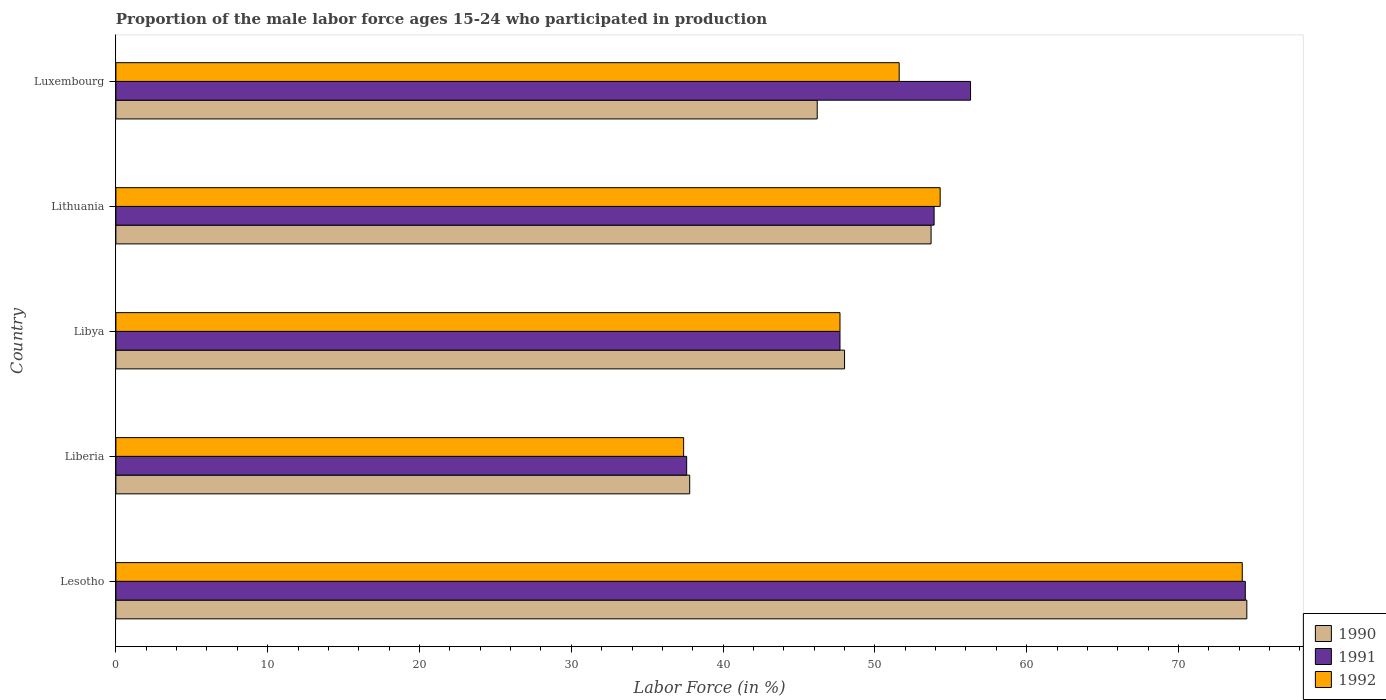How many different coloured bars are there?
Provide a short and direct response. 3. Are the number of bars per tick equal to the number of legend labels?
Provide a short and direct response. Yes. How many bars are there on the 2nd tick from the bottom?
Make the answer very short. 3. What is the label of the 3rd group of bars from the top?
Your answer should be very brief. Libya. In how many cases, is the number of bars for a given country not equal to the number of legend labels?
Give a very brief answer. 0. What is the proportion of the male labor force who participated in production in 1990 in Luxembourg?
Ensure brevity in your answer.  46.2. Across all countries, what is the maximum proportion of the male labor force who participated in production in 1990?
Ensure brevity in your answer.  74.5. Across all countries, what is the minimum proportion of the male labor force who participated in production in 1991?
Your response must be concise. 37.6. In which country was the proportion of the male labor force who participated in production in 1991 maximum?
Your response must be concise. Lesotho. In which country was the proportion of the male labor force who participated in production in 1992 minimum?
Offer a very short reply. Liberia. What is the total proportion of the male labor force who participated in production in 1990 in the graph?
Make the answer very short. 260.2. What is the difference between the proportion of the male labor force who participated in production in 1991 in Liberia and the proportion of the male labor force who participated in production in 1990 in Lithuania?
Your response must be concise. -16.1. What is the average proportion of the male labor force who participated in production in 1992 per country?
Provide a succinct answer. 53.04. What is the difference between the proportion of the male labor force who participated in production in 1990 and proportion of the male labor force who participated in production in 1991 in Libya?
Provide a short and direct response. 0.3. What is the ratio of the proportion of the male labor force who participated in production in 1990 in Liberia to that in Libya?
Your answer should be very brief. 0.79. What is the difference between the highest and the second highest proportion of the male labor force who participated in production in 1991?
Provide a succinct answer. 18.1. What is the difference between the highest and the lowest proportion of the male labor force who participated in production in 1990?
Provide a succinct answer. 36.7. What does the 2nd bar from the top in Lesotho represents?
Give a very brief answer. 1991. Is it the case that in every country, the sum of the proportion of the male labor force who participated in production in 1991 and proportion of the male labor force who participated in production in 1992 is greater than the proportion of the male labor force who participated in production in 1990?
Offer a very short reply. Yes. Are all the bars in the graph horizontal?
Ensure brevity in your answer.  Yes. How many countries are there in the graph?
Ensure brevity in your answer.  5. Does the graph contain grids?
Your answer should be very brief. No. Where does the legend appear in the graph?
Your answer should be very brief. Bottom right. How many legend labels are there?
Give a very brief answer. 3. How are the legend labels stacked?
Keep it short and to the point. Vertical. What is the title of the graph?
Make the answer very short. Proportion of the male labor force ages 15-24 who participated in production. Does "1971" appear as one of the legend labels in the graph?
Ensure brevity in your answer.  No. What is the label or title of the X-axis?
Your answer should be compact. Labor Force (in %). What is the Labor Force (in %) in 1990 in Lesotho?
Keep it short and to the point. 74.5. What is the Labor Force (in %) in 1991 in Lesotho?
Give a very brief answer. 74.4. What is the Labor Force (in %) in 1992 in Lesotho?
Offer a terse response. 74.2. What is the Labor Force (in %) in 1990 in Liberia?
Your answer should be very brief. 37.8. What is the Labor Force (in %) in 1991 in Liberia?
Give a very brief answer. 37.6. What is the Labor Force (in %) of 1992 in Liberia?
Your answer should be compact. 37.4. What is the Labor Force (in %) in 1991 in Libya?
Your response must be concise. 47.7. What is the Labor Force (in %) in 1992 in Libya?
Provide a succinct answer. 47.7. What is the Labor Force (in %) in 1990 in Lithuania?
Offer a very short reply. 53.7. What is the Labor Force (in %) in 1991 in Lithuania?
Ensure brevity in your answer.  53.9. What is the Labor Force (in %) of 1992 in Lithuania?
Make the answer very short. 54.3. What is the Labor Force (in %) of 1990 in Luxembourg?
Your answer should be compact. 46.2. What is the Labor Force (in %) in 1991 in Luxembourg?
Your answer should be compact. 56.3. What is the Labor Force (in %) in 1992 in Luxembourg?
Make the answer very short. 51.6. Across all countries, what is the maximum Labor Force (in %) in 1990?
Offer a very short reply. 74.5. Across all countries, what is the maximum Labor Force (in %) in 1991?
Provide a succinct answer. 74.4. Across all countries, what is the maximum Labor Force (in %) of 1992?
Keep it short and to the point. 74.2. Across all countries, what is the minimum Labor Force (in %) in 1990?
Your answer should be compact. 37.8. Across all countries, what is the minimum Labor Force (in %) of 1991?
Keep it short and to the point. 37.6. Across all countries, what is the minimum Labor Force (in %) of 1992?
Give a very brief answer. 37.4. What is the total Labor Force (in %) of 1990 in the graph?
Keep it short and to the point. 260.2. What is the total Labor Force (in %) in 1991 in the graph?
Provide a succinct answer. 269.9. What is the total Labor Force (in %) in 1992 in the graph?
Keep it short and to the point. 265.2. What is the difference between the Labor Force (in %) in 1990 in Lesotho and that in Liberia?
Your response must be concise. 36.7. What is the difference between the Labor Force (in %) of 1991 in Lesotho and that in Liberia?
Ensure brevity in your answer.  36.8. What is the difference between the Labor Force (in %) in 1992 in Lesotho and that in Liberia?
Keep it short and to the point. 36.8. What is the difference between the Labor Force (in %) of 1990 in Lesotho and that in Libya?
Keep it short and to the point. 26.5. What is the difference between the Labor Force (in %) in 1991 in Lesotho and that in Libya?
Offer a very short reply. 26.7. What is the difference between the Labor Force (in %) in 1990 in Lesotho and that in Lithuania?
Provide a short and direct response. 20.8. What is the difference between the Labor Force (in %) in 1991 in Lesotho and that in Lithuania?
Offer a terse response. 20.5. What is the difference between the Labor Force (in %) in 1992 in Lesotho and that in Lithuania?
Keep it short and to the point. 19.9. What is the difference between the Labor Force (in %) in 1990 in Lesotho and that in Luxembourg?
Your answer should be compact. 28.3. What is the difference between the Labor Force (in %) of 1992 in Lesotho and that in Luxembourg?
Your response must be concise. 22.6. What is the difference between the Labor Force (in %) of 1990 in Liberia and that in Libya?
Your answer should be compact. -10.2. What is the difference between the Labor Force (in %) of 1992 in Liberia and that in Libya?
Make the answer very short. -10.3. What is the difference between the Labor Force (in %) in 1990 in Liberia and that in Lithuania?
Your response must be concise. -15.9. What is the difference between the Labor Force (in %) in 1991 in Liberia and that in Lithuania?
Make the answer very short. -16.3. What is the difference between the Labor Force (in %) in 1992 in Liberia and that in Lithuania?
Give a very brief answer. -16.9. What is the difference between the Labor Force (in %) in 1990 in Liberia and that in Luxembourg?
Your response must be concise. -8.4. What is the difference between the Labor Force (in %) of 1991 in Liberia and that in Luxembourg?
Offer a very short reply. -18.7. What is the difference between the Labor Force (in %) of 1990 in Libya and that in Lithuania?
Keep it short and to the point. -5.7. What is the difference between the Labor Force (in %) in 1991 in Libya and that in Lithuania?
Give a very brief answer. -6.2. What is the difference between the Labor Force (in %) of 1992 in Libya and that in Lithuania?
Offer a very short reply. -6.6. What is the difference between the Labor Force (in %) in 1990 in Libya and that in Luxembourg?
Your answer should be very brief. 1.8. What is the difference between the Labor Force (in %) of 1992 in Libya and that in Luxembourg?
Your response must be concise. -3.9. What is the difference between the Labor Force (in %) of 1990 in Lithuania and that in Luxembourg?
Provide a short and direct response. 7.5. What is the difference between the Labor Force (in %) of 1991 in Lithuania and that in Luxembourg?
Give a very brief answer. -2.4. What is the difference between the Labor Force (in %) in 1990 in Lesotho and the Labor Force (in %) in 1991 in Liberia?
Ensure brevity in your answer.  36.9. What is the difference between the Labor Force (in %) of 1990 in Lesotho and the Labor Force (in %) of 1992 in Liberia?
Offer a very short reply. 37.1. What is the difference between the Labor Force (in %) in 1991 in Lesotho and the Labor Force (in %) in 1992 in Liberia?
Make the answer very short. 37. What is the difference between the Labor Force (in %) of 1990 in Lesotho and the Labor Force (in %) of 1991 in Libya?
Ensure brevity in your answer.  26.8. What is the difference between the Labor Force (in %) of 1990 in Lesotho and the Labor Force (in %) of 1992 in Libya?
Offer a terse response. 26.8. What is the difference between the Labor Force (in %) of 1991 in Lesotho and the Labor Force (in %) of 1992 in Libya?
Offer a very short reply. 26.7. What is the difference between the Labor Force (in %) in 1990 in Lesotho and the Labor Force (in %) in 1991 in Lithuania?
Offer a terse response. 20.6. What is the difference between the Labor Force (in %) in 1990 in Lesotho and the Labor Force (in %) in 1992 in Lithuania?
Your response must be concise. 20.2. What is the difference between the Labor Force (in %) in 1991 in Lesotho and the Labor Force (in %) in 1992 in Lithuania?
Ensure brevity in your answer.  20.1. What is the difference between the Labor Force (in %) of 1990 in Lesotho and the Labor Force (in %) of 1991 in Luxembourg?
Offer a very short reply. 18.2. What is the difference between the Labor Force (in %) of 1990 in Lesotho and the Labor Force (in %) of 1992 in Luxembourg?
Provide a short and direct response. 22.9. What is the difference between the Labor Force (in %) of 1991 in Lesotho and the Labor Force (in %) of 1992 in Luxembourg?
Keep it short and to the point. 22.8. What is the difference between the Labor Force (in %) of 1990 in Liberia and the Labor Force (in %) of 1992 in Libya?
Make the answer very short. -9.9. What is the difference between the Labor Force (in %) in 1991 in Liberia and the Labor Force (in %) in 1992 in Libya?
Your answer should be very brief. -10.1. What is the difference between the Labor Force (in %) in 1990 in Liberia and the Labor Force (in %) in 1991 in Lithuania?
Provide a succinct answer. -16.1. What is the difference between the Labor Force (in %) of 1990 in Liberia and the Labor Force (in %) of 1992 in Lithuania?
Ensure brevity in your answer.  -16.5. What is the difference between the Labor Force (in %) of 1991 in Liberia and the Labor Force (in %) of 1992 in Lithuania?
Make the answer very short. -16.7. What is the difference between the Labor Force (in %) in 1990 in Liberia and the Labor Force (in %) in 1991 in Luxembourg?
Ensure brevity in your answer.  -18.5. What is the difference between the Labor Force (in %) in 1991 in Liberia and the Labor Force (in %) in 1992 in Luxembourg?
Provide a short and direct response. -14. What is the difference between the Labor Force (in %) in 1990 in Libya and the Labor Force (in %) in 1991 in Lithuania?
Your answer should be very brief. -5.9. What is the difference between the Labor Force (in %) in 1990 in Libya and the Labor Force (in %) in 1992 in Luxembourg?
Keep it short and to the point. -3.6. What is the difference between the Labor Force (in %) of 1990 in Lithuania and the Labor Force (in %) of 1991 in Luxembourg?
Your response must be concise. -2.6. What is the difference between the Labor Force (in %) of 1991 in Lithuania and the Labor Force (in %) of 1992 in Luxembourg?
Ensure brevity in your answer.  2.3. What is the average Labor Force (in %) in 1990 per country?
Your answer should be compact. 52.04. What is the average Labor Force (in %) of 1991 per country?
Provide a succinct answer. 53.98. What is the average Labor Force (in %) in 1992 per country?
Ensure brevity in your answer.  53.04. What is the difference between the Labor Force (in %) in 1990 and Labor Force (in %) in 1991 in Lesotho?
Your answer should be compact. 0.1. What is the difference between the Labor Force (in %) in 1990 and Labor Force (in %) in 1992 in Lesotho?
Provide a short and direct response. 0.3. What is the difference between the Labor Force (in %) in 1990 and Labor Force (in %) in 1992 in Liberia?
Offer a terse response. 0.4. What is the difference between the Labor Force (in %) of 1991 and Labor Force (in %) of 1992 in Liberia?
Your response must be concise. 0.2. What is the difference between the Labor Force (in %) of 1991 and Labor Force (in %) of 1992 in Libya?
Give a very brief answer. 0. What is the difference between the Labor Force (in %) of 1990 and Labor Force (in %) of 1991 in Lithuania?
Ensure brevity in your answer.  -0.2. What is the difference between the Labor Force (in %) of 1991 and Labor Force (in %) of 1992 in Lithuania?
Give a very brief answer. -0.4. What is the ratio of the Labor Force (in %) in 1990 in Lesotho to that in Liberia?
Keep it short and to the point. 1.97. What is the ratio of the Labor Force (in %) of 1991 in Lesotho to that in Liberia?
Make the answer very short. 1.98. What is the ratio of the Labor Force (in %) in 1992 in Lesotho to that in Liberia?
Keep it short and to the point. 1.98. What is the ratio of the Labor Force (in %) of 1990 in Lesotho to that in Libya?
Provide a succinct answer. 1.55. What is the ratio of the Labor Force (in %) of 1991 in Lesotho to that in Libya?
Offer a terse response. 1.56. What is the ratio of the Labor Force (in %) in 1992 in Lesotho to that in Libya?
Your answer should be compact. 1.56. What is the ratio of the Labor Force (in %) in 1990 in Lesotho to that in Lithuania?
Provide a succinct answer. 1.39. What is the ratio of the Labor Force (in %) in 1991 in Lesotho to that in Lithuania?
Provide a short and direct response. 1.38. What is the ratio of the Labor Force (in %) of 1992 in Lesotho to that in Lithuania?
Your answer should be compact. 1.37. What is the ratio of the Labor Force (in %) of 1990 in Lesotho to that in Luxembourg?
Keep it short and to the point. 1.61. What is the ratio of the Labor Force (in %) in 1991 in Lesotho to that in Luxembourg?
Offer a very short reply. 1.32. What is the ratio of the Labor Force (in %) in 1992 in Lesotho to that in Luxembourg?
Your response must be concise. 1.44. What is the ratio of the Labor Force (in %) in 1990 in Liberia to that in Libya?
Your response must be concise. 0.79. What is the ratio of the Labor Force (in %) in 1991 in Liberia to that in Libya?
Your response must be concise. 0.79. What is the ratio of the Labor Force (in %) of 1992 in Liberia to that in Libya?
Provide a short and direct response. 0.78. What is the ratio of the Labor Force (in %) of 1990 in Liberia to that in Lithuania?
Provide a succinct answer. 0.7. What is the ratio of the Labor Force (in %) of 1991 in Liberia to that in Lithuania?
Your answer should be compact. 0.7. What is the ratio of the Labor Force (in %) of 1992 in Liberia to that in Lithuania?
Ensure brevity in your answer.  0.69. What is the ratio of the Labor Force (in %) of 1990 in Liberia to that in Luxembourg?
Keep it short and to the point. 0.82. What is the ratio of the Labor Force (in %) in 1991 in Liberia to that in Luxembourg?
Keep it short and to the point. 0.67. What is the ratio of the Labor Force (in %) in 1992 in Liberia to that in Luxembourg?
Provide a short and direct response. 0.72. What is the ratio of the Labor Force (in %) in 1990 in Libya to that in Lithuania?
Provide a succinct answer. 0.89. What is the ratio of the Labor Force (in %) of 1991 in Libya to that in Lithuania?
Give a very brief answer. 0.89. What is the ratio of the Labor Force (in %) in 1992 in Libya to that in Lithuania?
Your answer should be compact. 0.88. What is the ratio of the Labor Force (in %) in 1990 in Libya to that in Luxembourg?
Your response must be concise. 1.04. What is the ratio of the Labor Force (in %) of 1991 in Libya to that in Luxembourg?
Ensure brevity in your answer.  0.85. What is the ratio of the Labor Force (in %) in 1992 in Libya to that in Luxembourg?
Your answer should be compact. 0.92. What is the ratio of the Labor Force (in %) of 1990 in Lithuania to that in Luxembourg?
Offer a very short reply. 1.16. What is the ratio of the Labor Force (in %) of 1991 in Lithuania to that in Luxembourg?
Provide a short and direct response. 0.96. What is the ratio of the Labor Force (in %) in 1992 in Lithuania to that in Luxembourg?
Keep it short and to the point. 1.05. What is the difference between the highest and the second highest Labor Force (in %) of 1990?
Provide a succinct answer. 20.8. What is the difference between the highest and the lowest Labor Force (in %) in 1990?
Provide a short and direct response. 36.7. What is the difference between the highest and the lowest Labor Force (in %) in 1991?
Offer a terse response. 36.8. What is the difference between the highest and the lowest Labor Force (in %) of 1992?
Give a very brief answer. 36.8. 